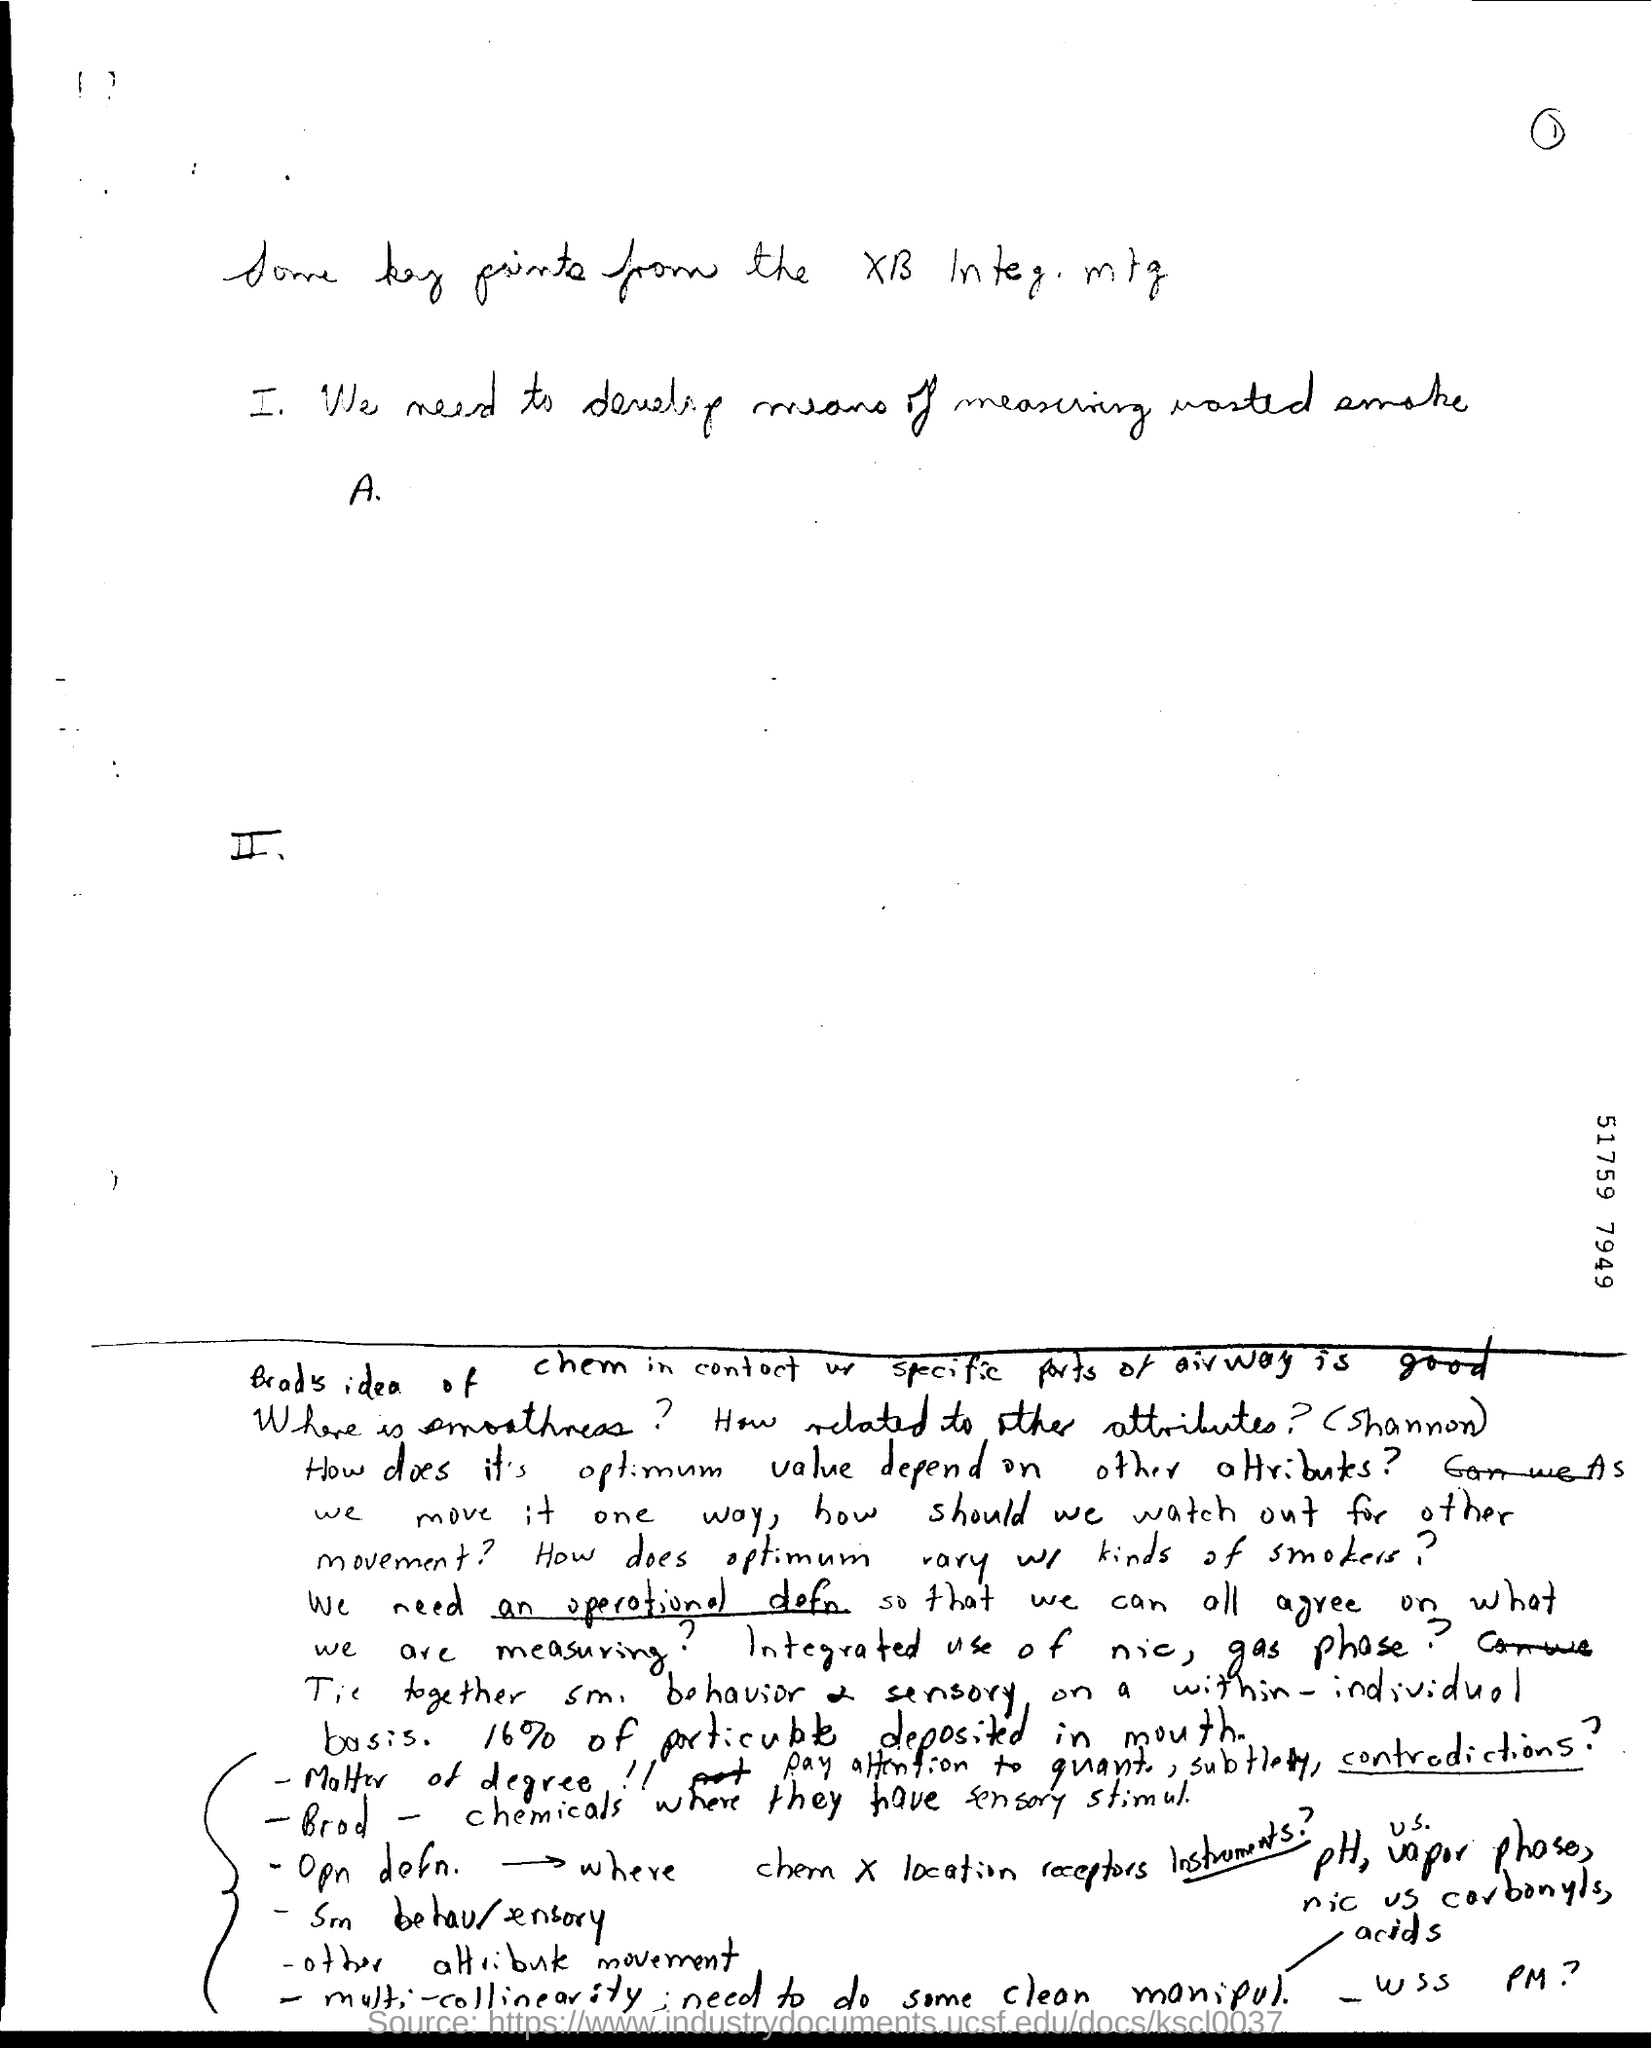List a handful of essential elements in this visual. The number specified on the right side of the document is 51759. The page number mentioned in this document is 1.. 